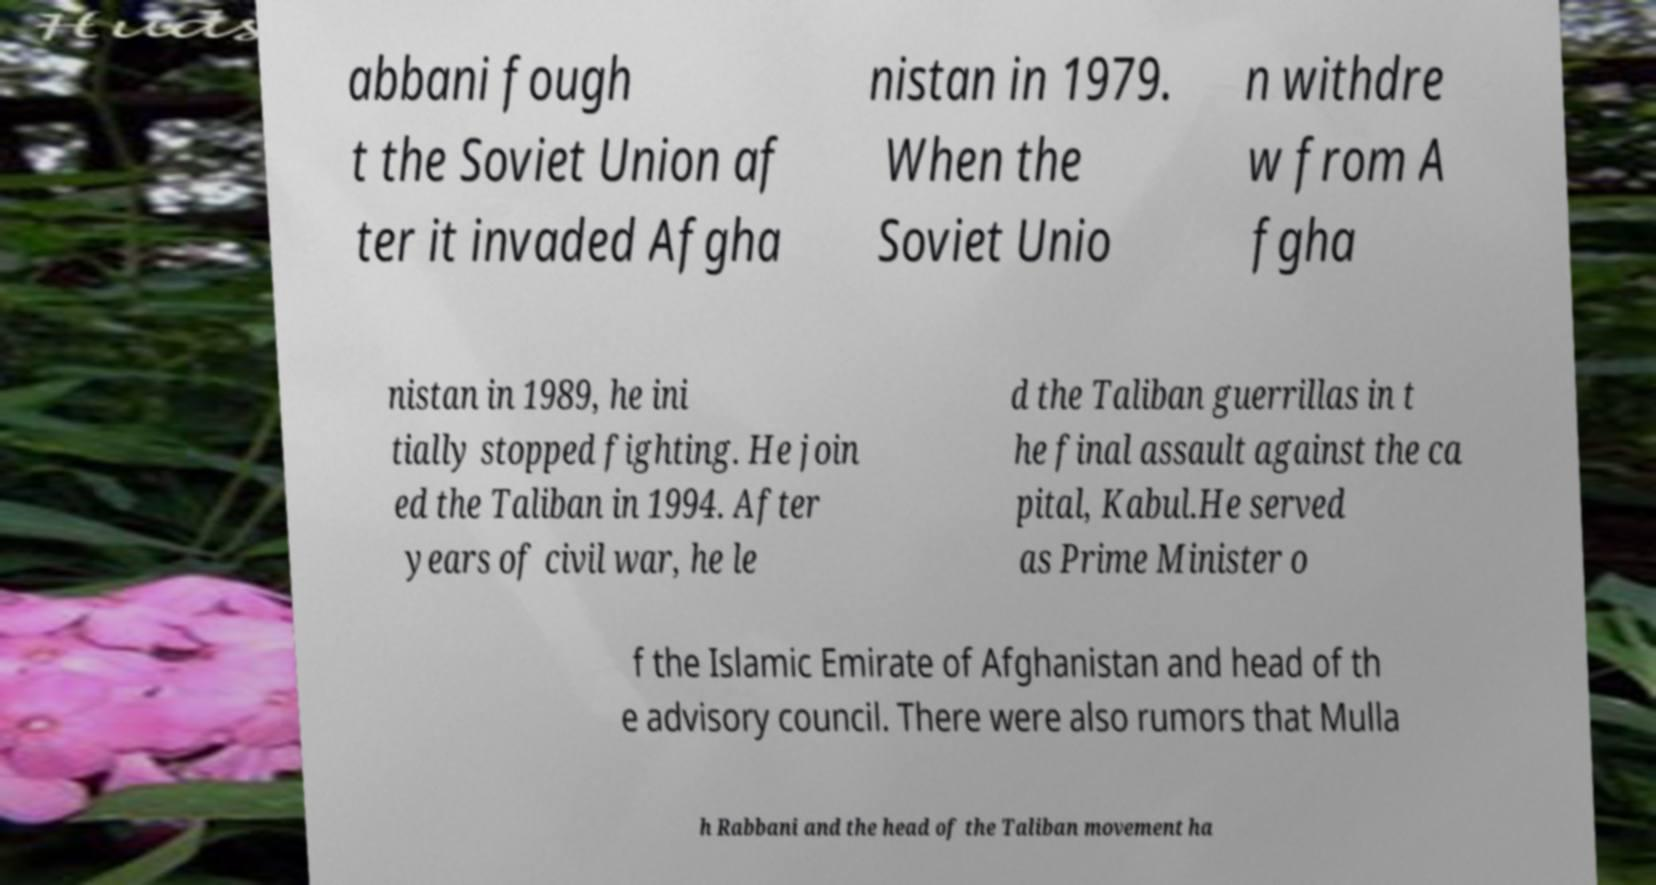Can you accurately transcribe the text from the provided image for me? abbani fough t the Soviet Union af ter it invaded Afgha nistan in 1979. When the Soviet Unio n withdre w from A fgha nistan in 1989, he ini tially stopped fighting. He join ed the Taliban in 1994. After years of civil war, he le d the Taliban guerrillas in t he final assault against the ca pital, Kabul.He served as Prime Minister o f the Islamic Emirate of Afghanistan and head of th e advisory council. There were also rumors that Mulla h Rabbani and the head of the Taliban movement ha 